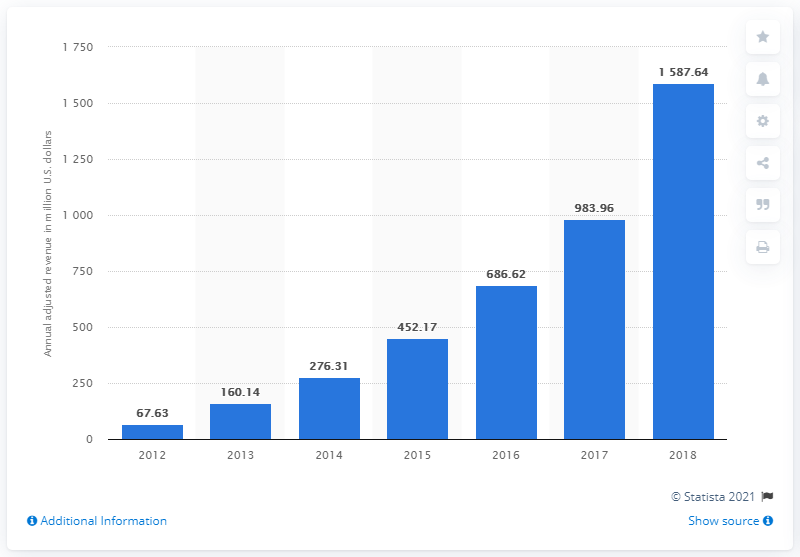Indicate a few pertinent items in this graphic. In the most recent fiscal period, Square's net revenue, excluding Starbucks transaction revenues and transaction-based costs, was $1,587.64. In the previous year, Square's net revenue was approximately $983.96. 